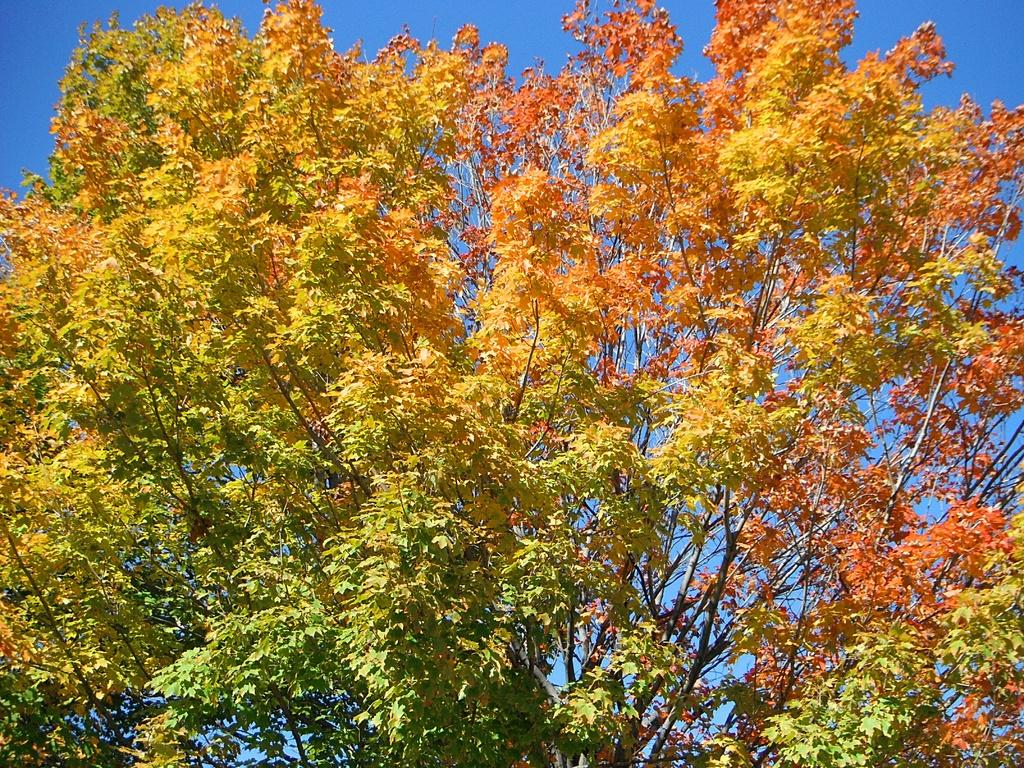What is the main subject in the center of the image? There is a tree in the center of the image. What can be seen at the top of the image? The sky is visible at the top of the image. What type of insurance is being discussed in the image? There is no discussion of insurance in the image, as it primarily features a tree and the sky. 